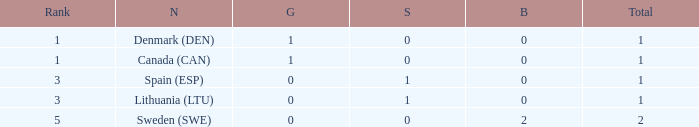What is the total when there were less than 0 bronze? 0.0. 